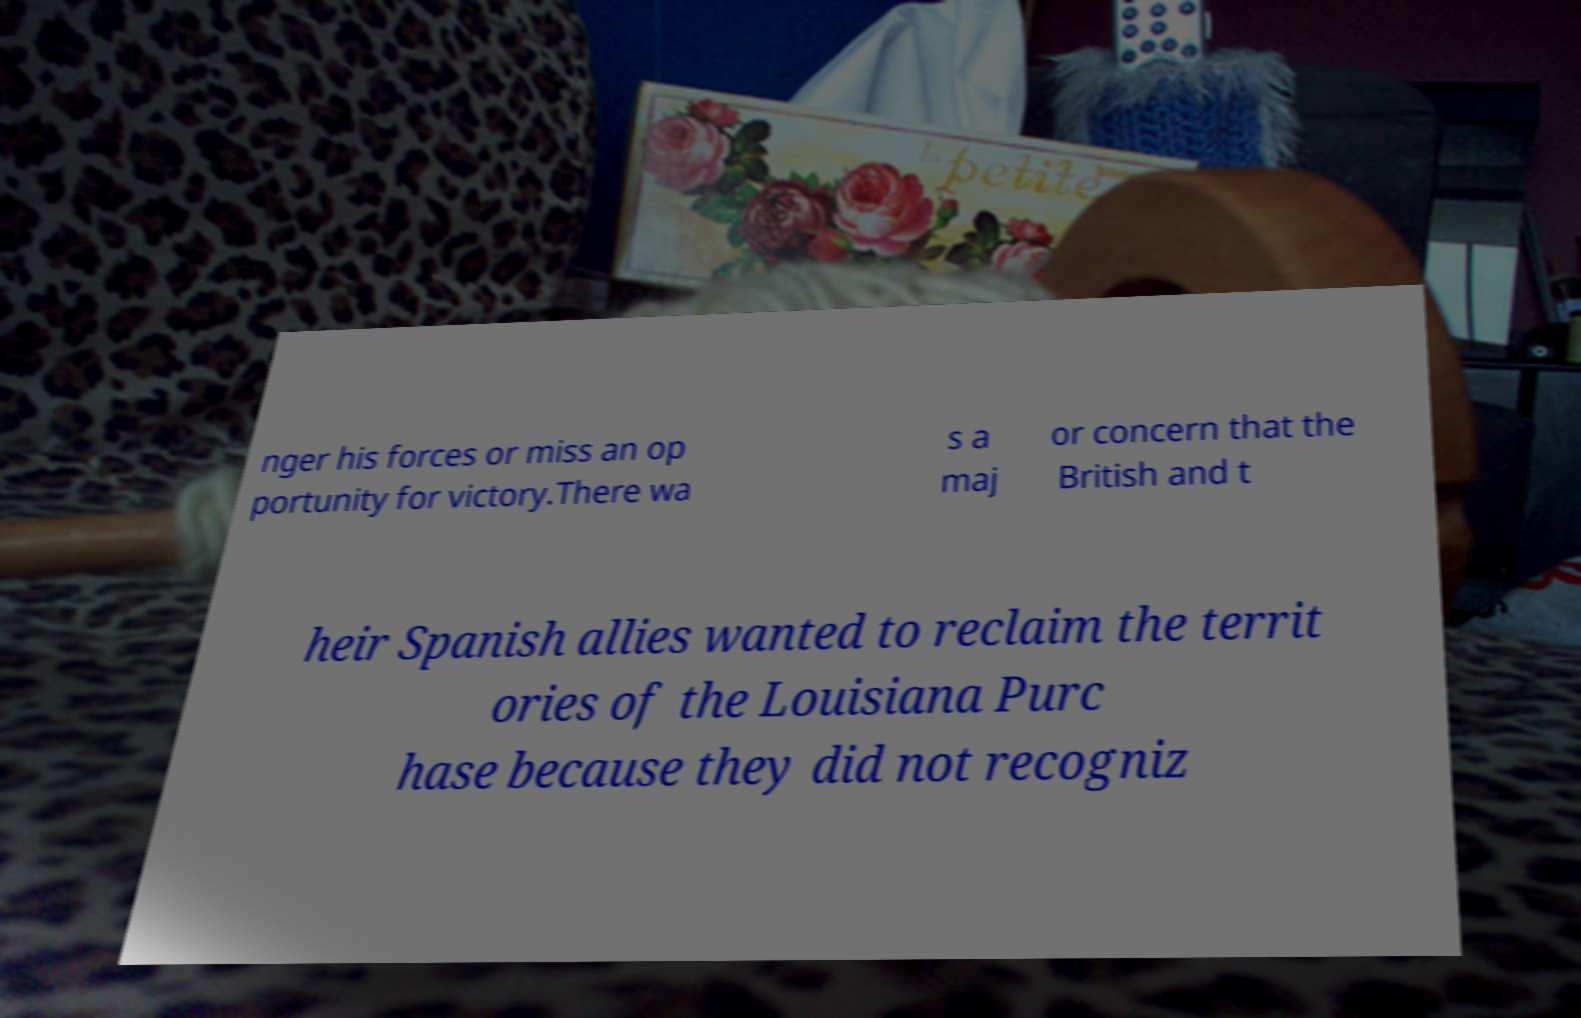Could you assist in decoding the text presented in this image and type it out clearly? nger his forces or miss an op portunity for victory.There wa s a maj or concern that the British and t heir Spanish allies wanted to reclaim the territ ories of the Louisiana Purc hase because they did not recogniz 